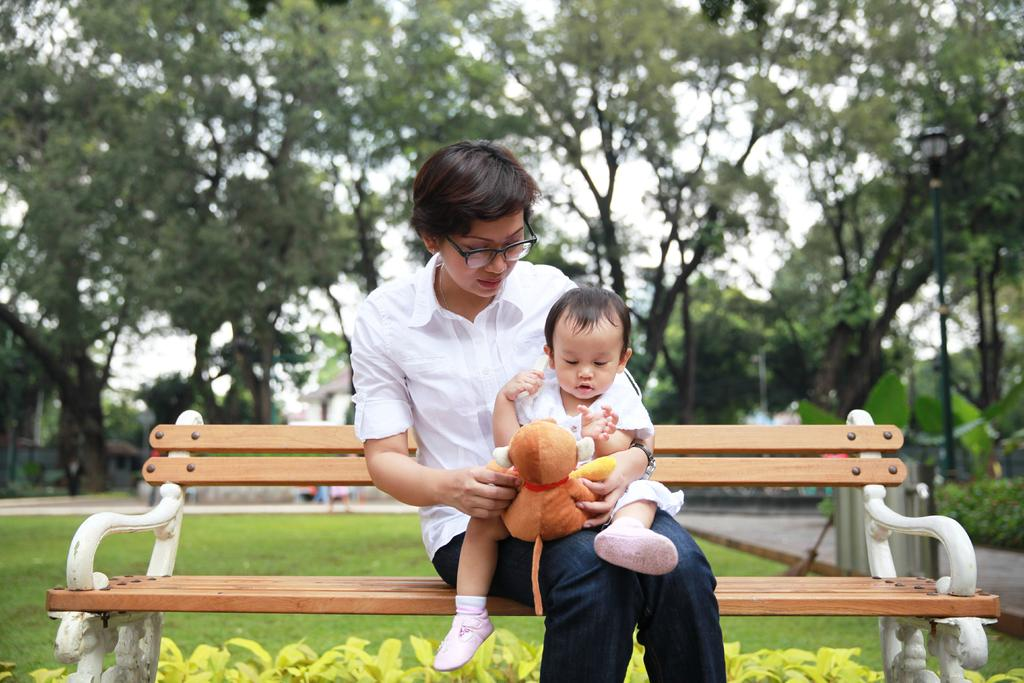Who is present in the image? There is a woman and a child in the image. What are the woman and child doing in the image? The woman and child are sitting on a bench. What is the woman holding in the image? The woman is holding a soft toy. What can be seen in the background of the image? There are trees in the background of the image. What type of action is the zephyr performing in the image? There is no mention of a zephyr in the image, so it cannot be performing any actions. 